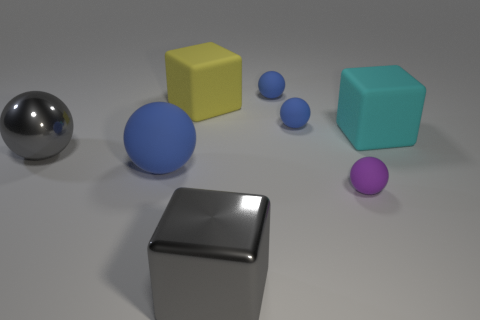Subtract all purple blocks. How many blue balls are left? 3 Add 1 large cyan things. How many objects exist? 9 Subtract all red spheres. Subtract all gray cubes. How many spheres are left? 5 Subtract all cubes. How many objects are left? 5 Add 2 rubber spheres. How many rubber spheres are left? 6 Add 3 big metallic blocks. How many big metallic blocks exist? 4 Subtract 0 purple blocks. How many objects are left? 8 Subtract all tiny rubber spheres. Subtract all cyan rubber things. How many objects are left? 4 